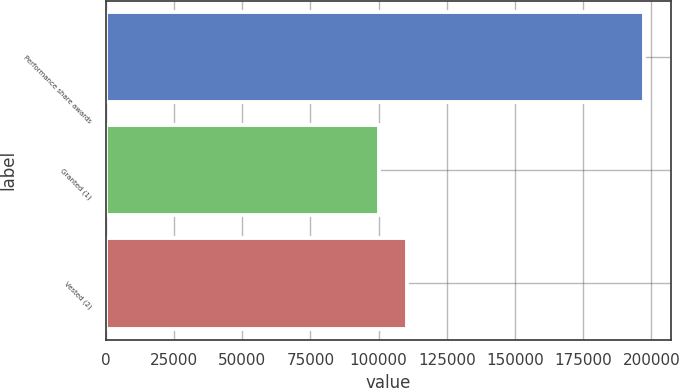Convert chart. <chart><loc_0><loc_0><loc_500><loc_500><bar_chart><fcel>Performance share awards<fcel>Granted (1)<fcel>Vested (2)<nl><fcel>197249<fcel>100170<fcel>110428<nl></chart> 